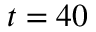Convert formula to latex. <formula><loc_0><loc_0><loc_500><loc_500>t = 4 0</formula> 